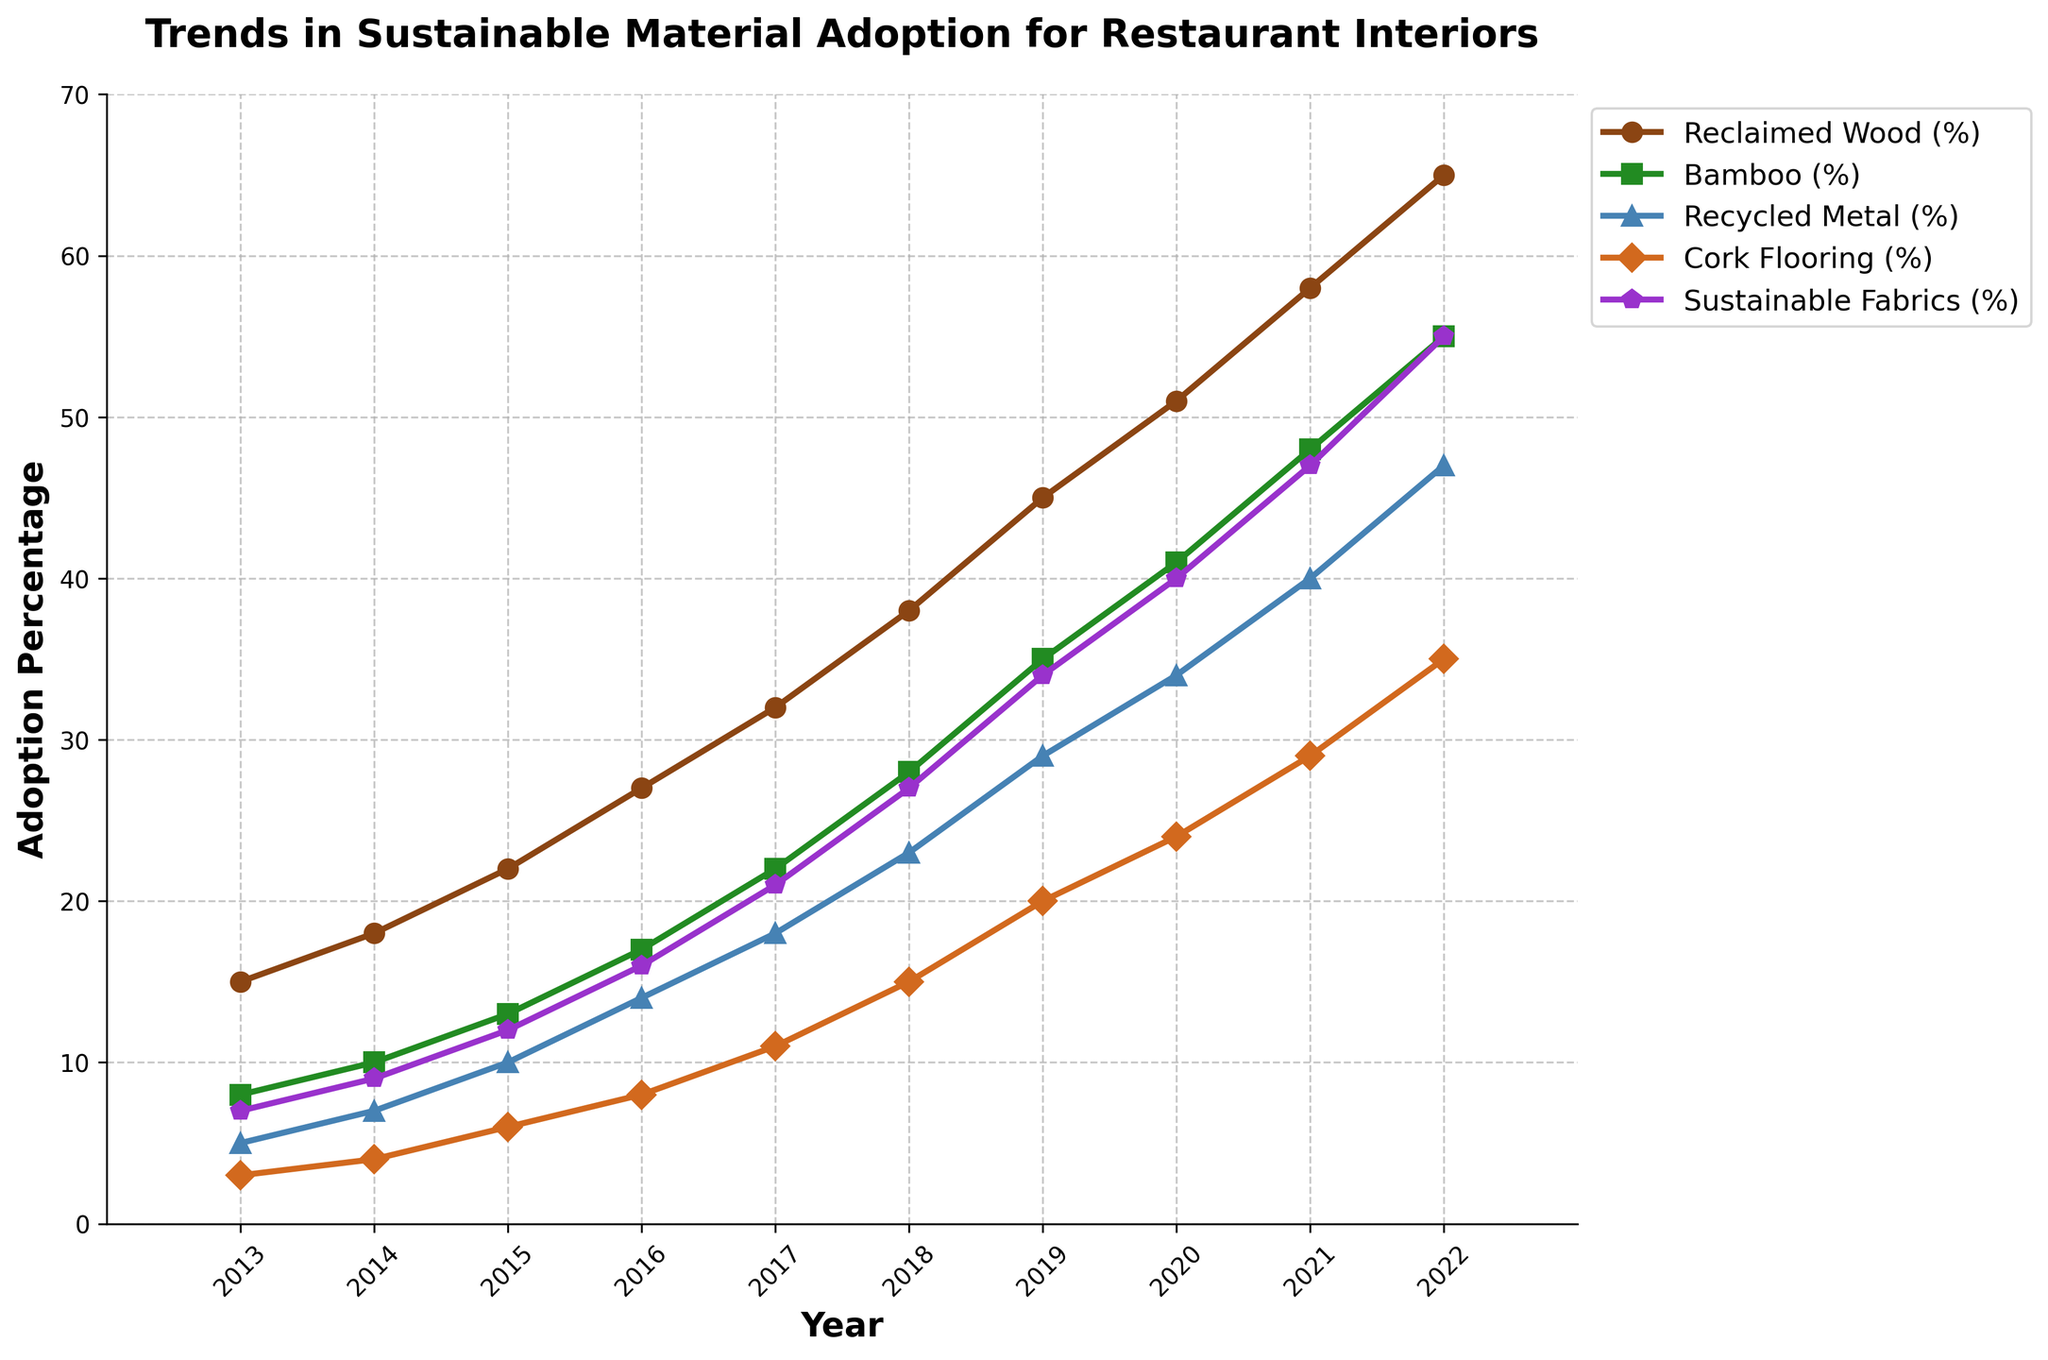Which year saw the highest adoption percentage for Reclaimed Wood? To find the highest adoption percentage for Reclaimed Wood, we look at the 'Reclaimed Wood (%)' line and see which year has the highest value. The maximum value is 65% in the year 2022.
Answer: 2022 Which material showed the steepest increase in adoption percentage between 2014 and 2020? To determine the steepest increase, we need to calculate the difference in adoption percentages between 2014 and 2020 for each material. Reclaimed Wood increased by 33% (51-18), Bamboo by 31% (41-10), Recycled Metal by 27% (34-7), Cork Flooring by 20% (24-4), and Sustainable Fabrics by 31% (40-9). The steepest increases are for Reclaimed Wood and Bamboo, both by 33% and 31% respectively.
Answer: Reclaimed Wood How much higher was the adoption percentage for Sustainable Fabrics in 2021 compared to Bamboo in the same year? First, we find the adoption percentage for Sustainable Fabrics in 2021, which is 47%. Then, we find the adoption percentage for Bamboo in 2021, which is 48%. The difference is calculated as 47 - 48 = -1, indicating that the adoption for Sustainable Fabrics was actually 1% lower.
Answer: 1% lower What is the overall trend in Recycled Metal adoption from 2013 to 2022? To determine the overall trend, we observe the line representing Recycled Metal (%). The trend is consistently upward from 5% in 2013 to 47% in 2022, indicating steadily increasing adoption.
Answer: Increasing How does the 2022 adoption percentage of Cork Flooring compare to its 2017 adoption percentage? To compare the 2022 and 2017 values, we look at the Cork Flooring line for these years. In 2022, the adoption percentage is 35%, while in 2017 it is 11%. The difference is 35% - 11% = 24%. Thus, the adoption percentage significantly increased.
Answer: Significantly higher Which material had the smallest increase in adoption percentage from 2013 to 2015? To find the material with the smallest increase, we calculate the differences for each material between 2013 and 2015. Reclaimed Wood: 22 - 15 = 7%, Bamboo: 13 - 8 = 5%, Recycled Metal: 10 - 5 = 5%, Cork Flooring: 6 - 3 = 3%, Sustainable Fabrics: 12 - 7 = 5%. The smallest increase was for Cork Flooring, 3%.
Answer: Cork Flooring In which year did Bamboo become more widely adopted than Recycled Metal? We find when the value for Bamboo surpasses that for Recycled Metal by comparing their respective lines year by year. This happens first in 2016, where Bamboo (17%) exceeds Recycled Metal (14%).
Answer: 2016 What was the total adoption percentage for all materials combined in 2019? To get the total adoption percentage in 2019, we sum up the values for all materials: 45% (Reclaimed Wood) + 35% (Bamboo) + 29% (Recycled Metal) + 20% (Cork Flooring) + 34% (Sustainable Fabrics) = 163%.
Answer: 163% Which year saw the first occurrence of over 50% adoption in any of the materials? We need to identify the earliest year when any material's line crosses 50%. For Reclaimed Wood, this first happens in 2020 with 51%.
Answer: 2020 